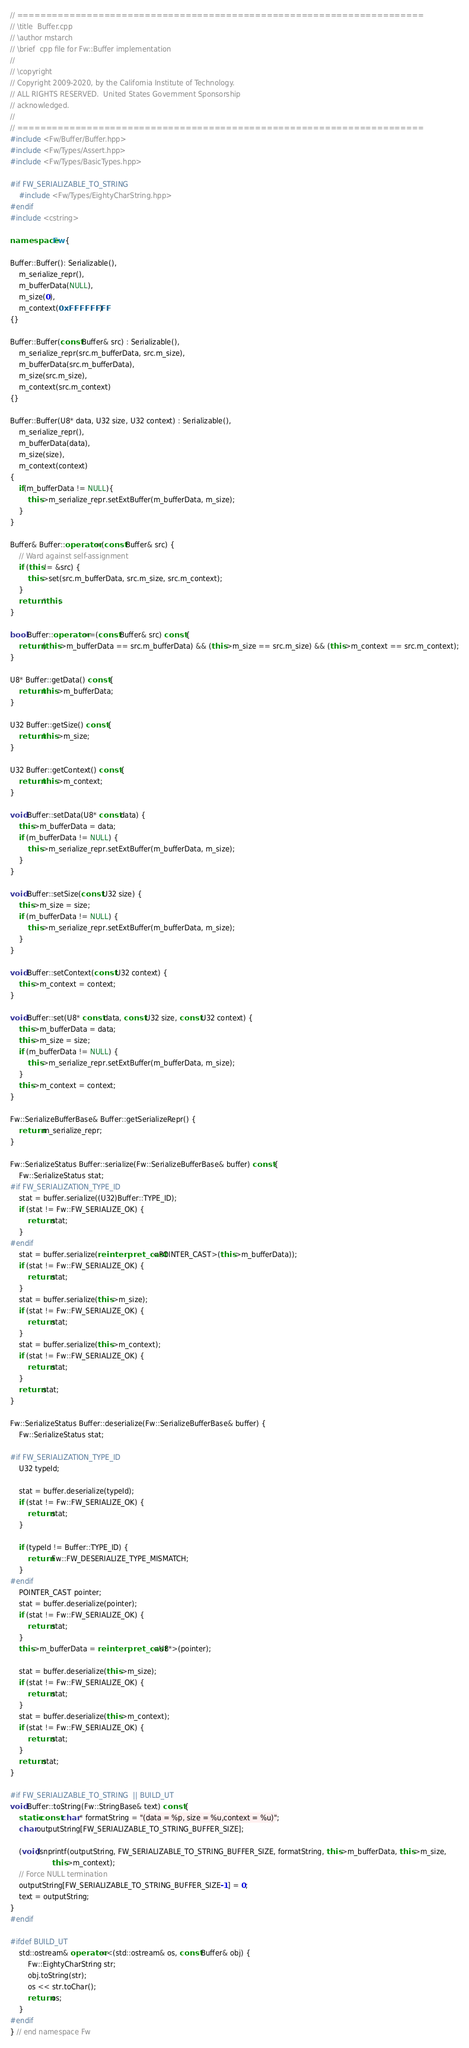Convert code to text. <code><loc_0><loc_0><loc_500><loc_500><_C++_>// ======================================================================
// \title  Buffer.cpp
// \author mstarch
// \brief  cpp file for Fw::Buffer implementation
//
// \copyright
// Copyright 2009-2020, by the California Institute of Technology.
// ALL RIGHTS RESERVED.  United States Government Sponsorship
// acknowledged.
//
// ======================================================================
#include <Fw/Buffer/Buffer.hpp>
#include <Fw/Types/Assert.hpp>
#include <Fw/Types/BasicTypes.hpp>

#if FW_SERIALIZABLE_TO_STRING
    #include <Fw/Types/EightyCharString.hpp>
#endif
#include <cstring>

namespace Fw {

Buffer::Buffer(): Serializable(),
    m_serialize_repr(),
    m_bufferData(NULL),
    m_size(0),
    m_context(0xFFFFFFFF)
{}

Buffer::Buffer(const Buffer& src) : Serializable(),
    m_serialize_repr(src.m_bufferData, src.m_size),
    m_bufferData(src.m_bufferData),
    m_size(src.m_size),
    m_context(src.m_context)
{}

Buffer::Buffer(U8* data, U32 size, U32 context) : Serializable(),
    m_serialize_repr(),
    m_bufferData(data),
    m_size(size),
    m_context(context)
{
    if(m_bufferData != NULL){
        this->m_serialize_repr.setExtBuffer(m_bufferData, m_size);
    }
}

Buffer& Buffer::operator=(const Buffer& src) {
    // Ward against self-assignment
    if (this != &src) {
        this->set(src.m_bufferData, src.m_size, src.m_context);
    }
    return *this;
}

bool Buffer::operator==(const Buffer& src) const {
    return (this->m_bufferData == src.m_bufferData) && (this->m_size == src.m_size) && (this->m_context == src.m_context);
}

U8* Buffer::getData() const {
    return this->m_bufferData;
}

U32 Buffer::getSize() const {
    return this->m_size;
}

U32 Buffer::getContext() const {
    return this->m_context;
}

void Buffer::setData(U8* const data) {
    this->m_bufferData = data;
    if (m_bufferData != NULL) {
        this->m_serialize_repr.setExtBuffer(m_bufferData, m_size);
    }
}

void Buffer::setSize(const U32 size) {
    this->m_size = size;
    if (m_bufferData != NULL) {
        this->m_serialize_repr.setExtBuffer(m_bufferData, m_size);
    }
}

void Buffer::setContext(const U32 context) {
    this->m_context = context;
}

void Buffer::set(U8* const data, const U32 size, const U32 context) {
    this->m_bufferData = data;
    this->m_size = size;
    if (m_bufferData != NULL) {
        this->m_serialize_repr.setExtBuffer(m_bufferData, m_size);
    }
    this->m_context = context;
}

Fw::SerializeBufferBase& Buffer::getSerializeRepr() {
    return m_serialize_repr;
}

Fw::SerializeStatus Buffer::serialize(Fw::SerializeBufferBase& buffer) const {
    Fw::SerializeStatus stat;
#if FW_SERIALIZATION_TYPE_ID
    stat = buffer.serialize((U32)Buffer::TYPE_ID);
    if (stat != Fw::FW_SERIALIZE_OK) {
        return stat;
    }
#endif
    stat = buffer.serialize(reinterpret_cast<POINTER_CAST>(this->m_bufferData));
    if (stat != Fw::FW_SERIALIZE_OK) {
        return stat;
    }
    stat = buffer.serialize(this->m_size);
    if (stat != Fw::FW_SERIALIZE_OK) {
        return stat;
    }
    stat = buffer.serialize(this->m_context);
    if (stat != Fw::FW_SERIALIZE_OK) {
        return stat;
    }
    return stat;
}

Fw::SerializeStatus Buffer::deserialize(Fw::SerializeBufferBase& buffer) {
    Fw::SerializeStatus stat;

#if FW_SERIALIZATION_TYPE_ID
    U32 typeId;

    stat = buffer.deserialize(typeId);
    if (stat != Fw::FW_SERIALIZE_OK) {
        return stat;
    }

    if (typeId != Buffer::TYPE_ID) {
        return Fw::FW_DESERIALIZE_TYPE_MISMATCH;
    }
#endif
    POINTER_CAST pointer;
    stat = buffer.deserialize(pointer);
    if (stat != Fw::FW_SERIALIZE_OK) {
        return stat;
    }
    this->m_bufferData = reinterpret_cast<U8*>(pointer);

    stat = buffer.deserialize(this->m_size);
    if (stat != Fw::FW_SERIALIZE_OK) {
        return stat;
    }
    stat = buffer.deserialize(this->m_context);
    if (stat != Fw::FW_SERIALIZE_OK) {
        return stat;
    }
    return stat;
}

#if FW_SERIALIZABLE_TO_STRING  || BUILD_UT
void Buffer::toString(Fw::StringBase& text) const {
    static const char * formatString = "(data = %p, size = %u,context = %u)";
    char outputString[FW_SERIALIZABLE_TO_STRING_BUFFER_SIZE];

    (void)snprintf(outputString, FW_SERIALIZABLE_TO_STRING_BUFFER_SIZE, formatString, this->m_bufferData, this->m_size,
                   this->m_context);
    // Force NULL termination
    outputString[FW_SERIALIZABLE_TO_STRING_BUFFER_SIZE-1] = 0;
    text = outputString;
}
#endif

#ifdef BUILD_UT
    std::ostream& operator<<(std::ostream& os, const Buffer& obj) {
        Fw::EightyCharString str;
        obj.toString(str);
        os << str.toChar();
        return os;
    }
#endif
} // end namespace Fw
</code> 